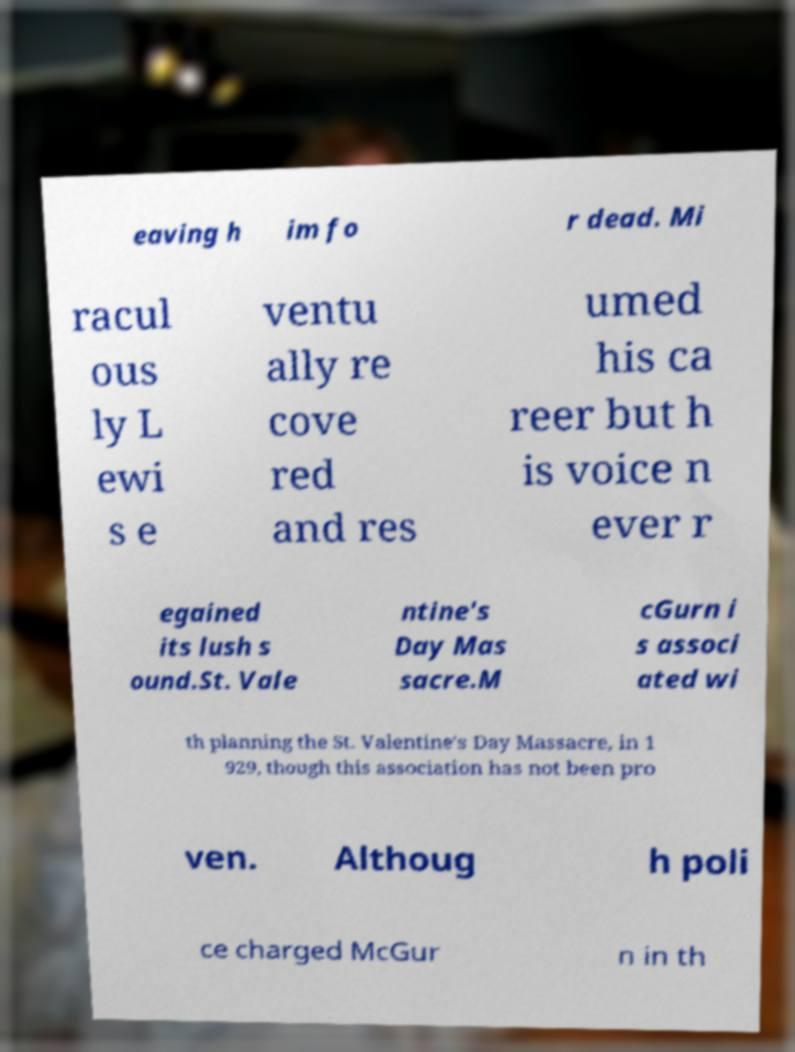There's text embedded in this image that I need extracted. Can you transcribe it verbatim? eaving h im fo r dead. Mi racul ous ly L ewi s e ventu ally re cove red and res umed his ca reer but h is voice n ever r egained its lush s ound.St. Vale ntine's Day Mas sacre.M cGurn i s associ ated wi th planning the St. Valentine's Day Massacre, in 1 929, though this association has not been pro ven. Althoug h poli ce charged McGur n in th 